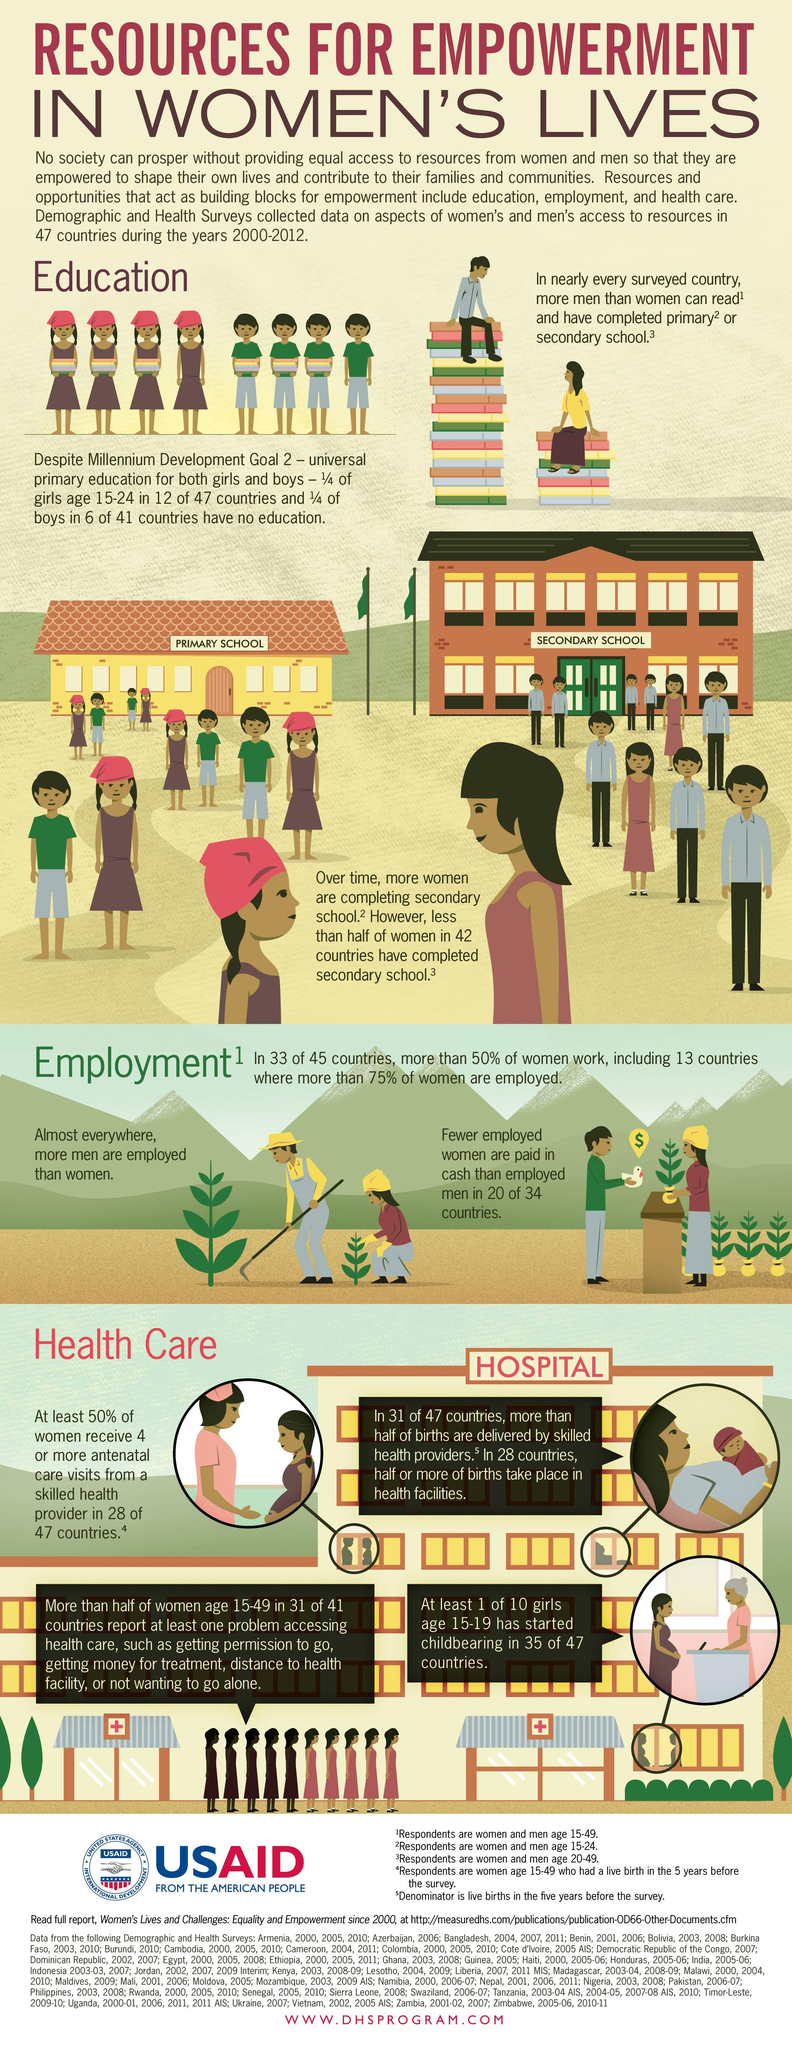Mention a couple of crucial points in this snapshot. Out of the ten students in primary school, five girls attended. According to available data, approximately 50% of women between the age of 15 and 49 lack access to healthcare. It is estimated that out of ten students who attended secondary school, only two of them were girls. 